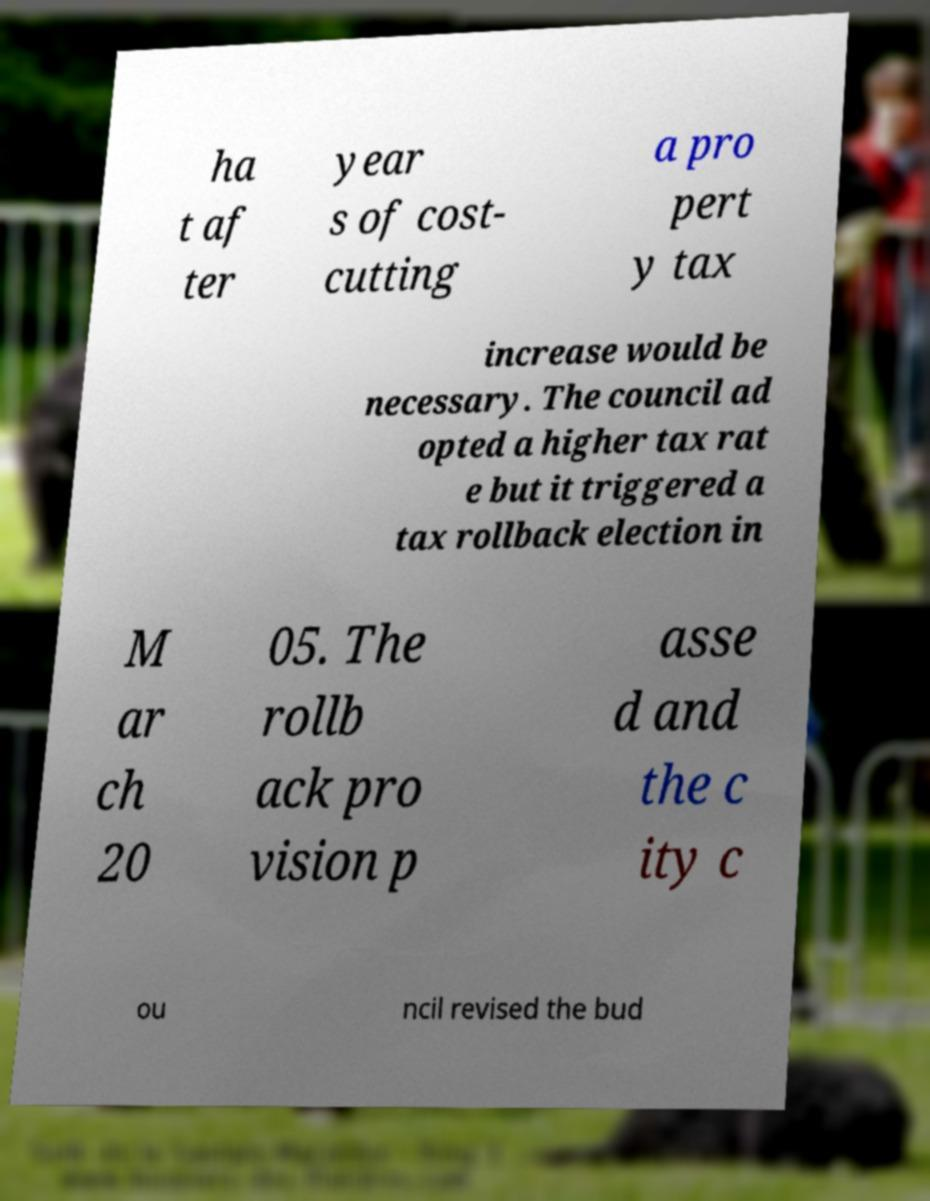Could you assist in decoding the text presented in this image and type it out clearly? ha t af ter year s of cost- cutting a pro pert y tax increase would be necessary. The council ad opted a higher tax rat e but it triggered a tax rollback election in M ar ch 20 05. The rollb ack pro vision p asse d and the c ity c ou ncil revised the bud 